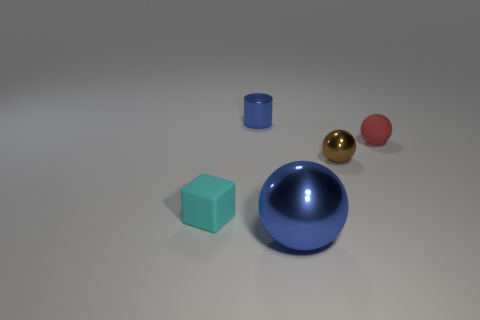What is the color of the other shiny thing that is the same shape as the big blue object?
Ensure brevity in your answer.  Brown. What number of small blue shiny things are behind the rubber thing that is in front of the tiny metallic sphere?
Your answer should be compact. 1. What number of blocks are blue things or brown things?
Offer a very short reply. 0. Are there any small shiny cylinders?
Keep it short and to the point. Yes. What is the size of the other shiny thing that is the same shape as the brown shiny thing?
Your answer should be compact. Large. What shape is the tiny thing in front of the shiny sphere behind the cyan thing?
Make the answer very short. Cube. What number of cyan things are shiny cylinders or big things?
Give a very brief answer. 0. The tiny matte cube is what color?
Your answer should be compact. Cyan. Is the blue shiny cylinder the same size as the red sphere?
Make the answer very short. Yes. Is there anything else that is the same shape as the small red matte thing?
Your answer should be very brief. Yes. 